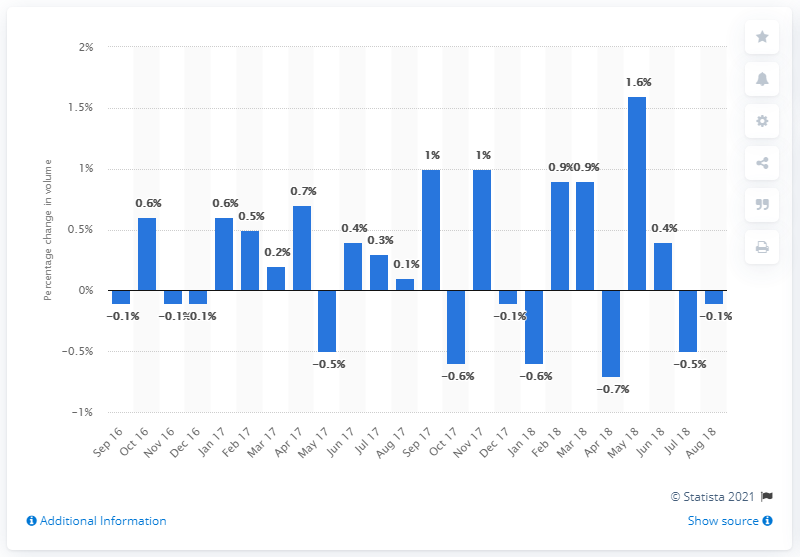List a handful of essential elements in this visual. In August 2018, the volume of food, drink, and tobacco retail decreased by 0.1%. 